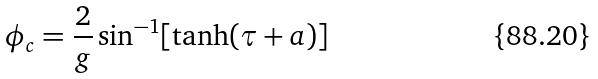<formula> <loc_0><loc_0><loc_500><loc_500>\phi _ { c } = \frac { 2 } { g } \sin ^ { - 1 } [ \tanh ( \tau + a ) ]</formula> 